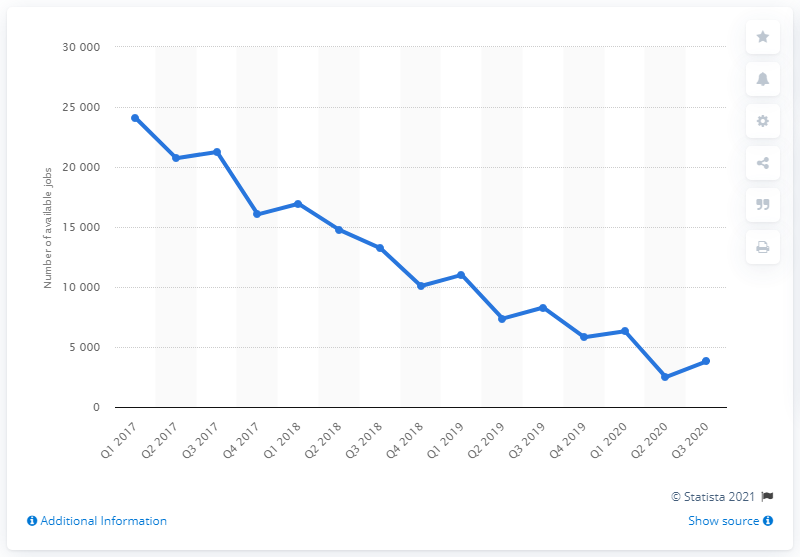Identify some key points in this picture. During the first quarter of 2017, a total of 24,105 new financial positions were offered on the London job market. In the second quarter of 2020, a total of 2490 financial services jobs were offered. 